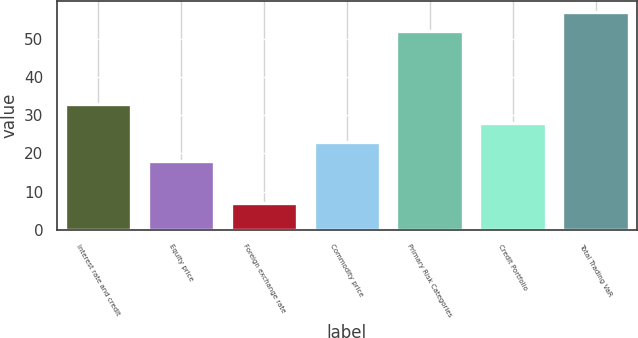<chart> <loc_0><loc_0><loc_500><loc_500><bar_chart><fcel>Interest rate and credit<fcel>Equity price<fcel>Foreign exchange rate<fcel>Commodity price<fcel>Primary Risk Categories<fcel>Credit Portfolio<fcel>Total Trading VaR<nl><fcel>33<fcel>18<fcel>7<fcel>23<fcel>52<fcel>28<fcel>57<nl></chart> 